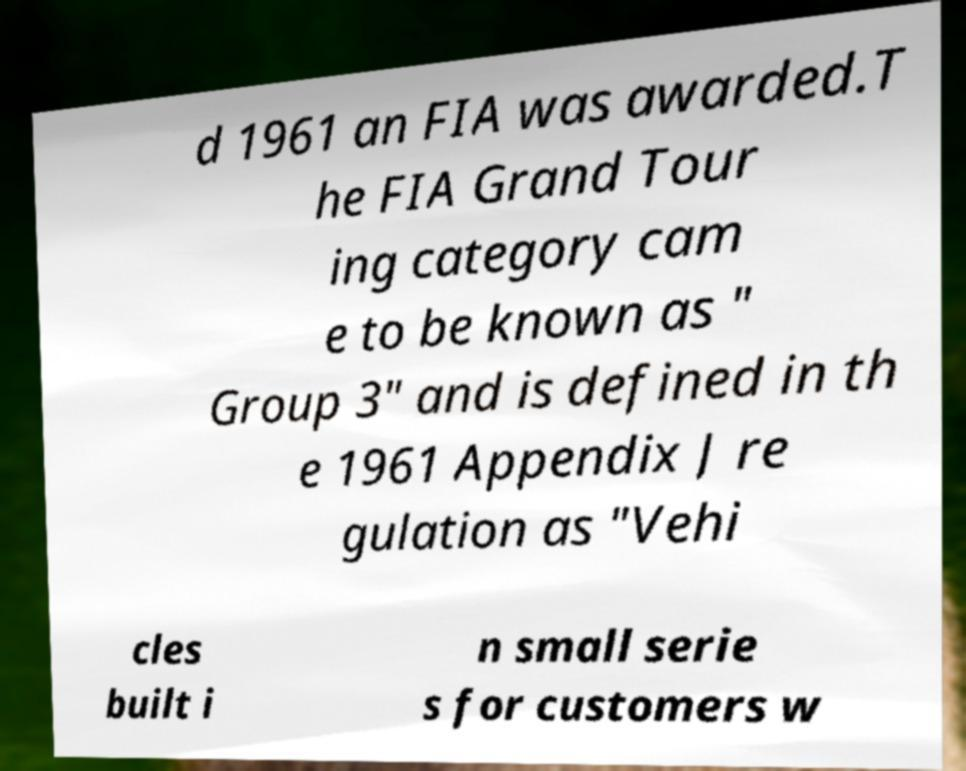Please read and relay the text visible in this image. What does it say? d 1961 an FIA was awarded.T he FIA Grand Tour ing category cam e to be known as " Group 3" and is defined in th e 1961 Appendix J re gulation as "Vehi cles built i n small serie s for customers w 